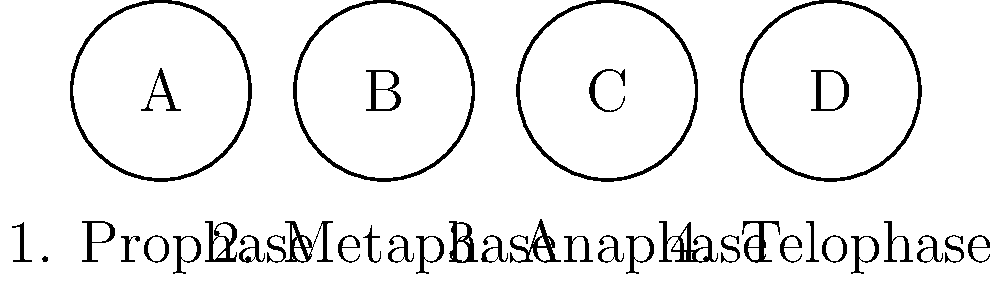As a young British woman interested in healthcare, you're studying cell division. The images above represent different stages of mitosis as seen under a microscope. Which stage is characterized by the alignment of chromosomes along the cell's equator? To answer this question, let's review the stages of mitosis:

1. Prophase (A): Chromosomes condense and become visible. The nuclear envelope breaks down.

2. Metaphase (B): Chromosomes align along the cell's equator (middle). This is the key characteristic of this stage.

3. Anaphase (C): Sister chromatids separate and move to opposite poles of the cell.

4. Telophase (D): Chromosomes decondense, and the nuclear envelope reforms around each set.

The question asks about the stage where chromosomes align at the cell's equator. This alignment is the defining feature of metaphase, which is represented by image B in the diagram.
Answer: Metaphase 